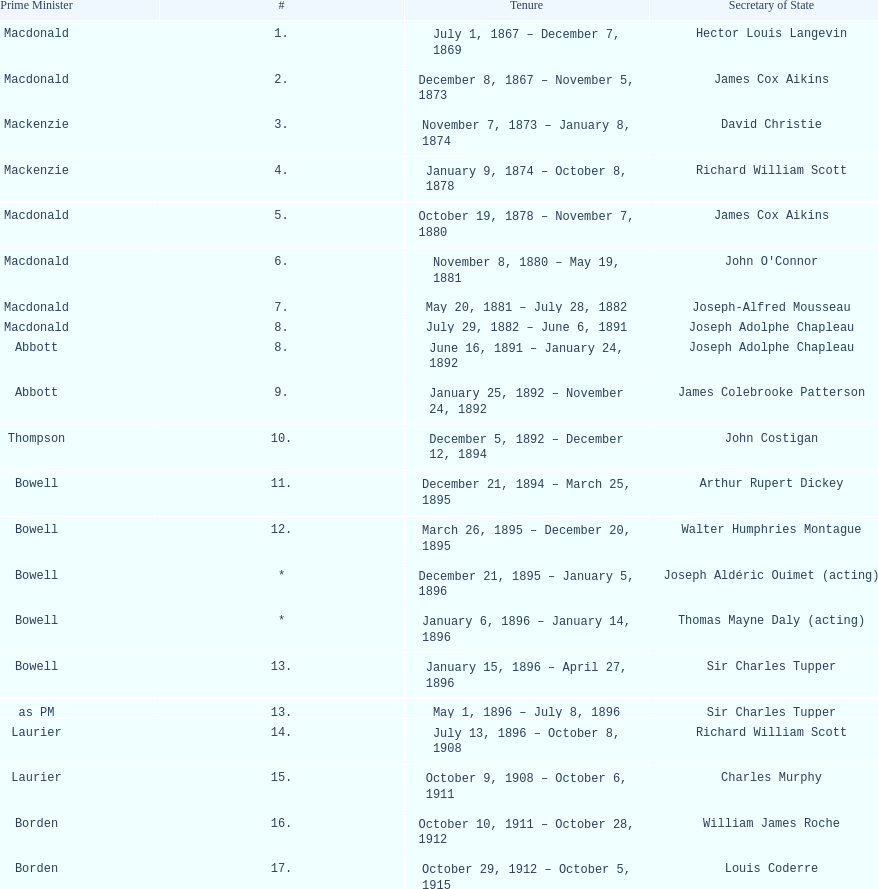Was macdonald prime minister before or after bowell? Before. 